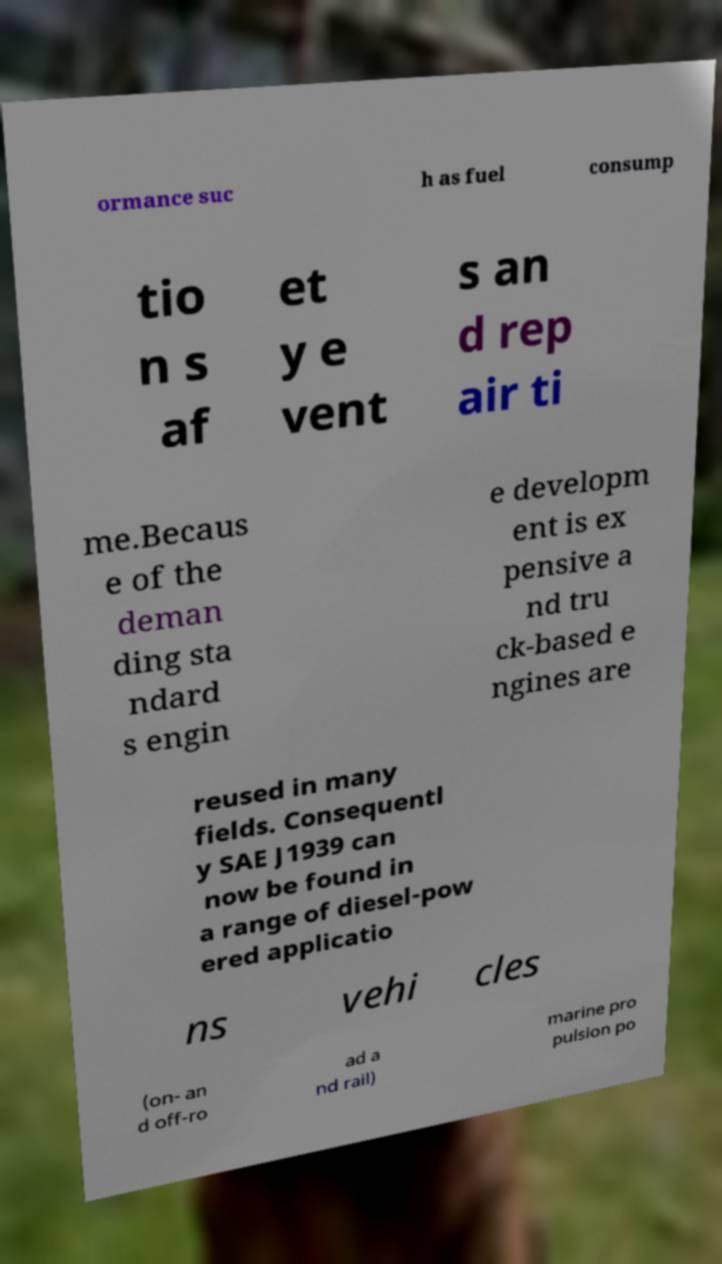I need the written content from this picture converted into text. Can you do that? ormance suc h as fuel consump tio n s af et y e vent s an d rep air ti me.Becaus e of the deman ding sta ndard s engin e developm ent is ex pensive a nd tru ck-based e ngines are reused in many fields. Consequentl y SAE J1939 can now be found in a range of diesel-pow ered applicatio ns vehi cles (on- an d off-ro ad a nd rail) marine pro pulsion po 